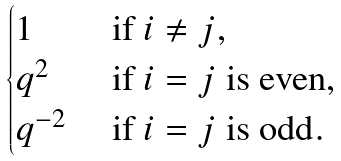<formula> <loc_0><loc_0><loc_500><loc_500>\begin{cases} 1 & \ \text {if } i \ne j , \\ q ^ { 2 } & \ \text {if $i=j$ is even} , \\ q ^ { - 2 } & \ \text {if $i=j$ is odd} . \end{cases}</formula> 